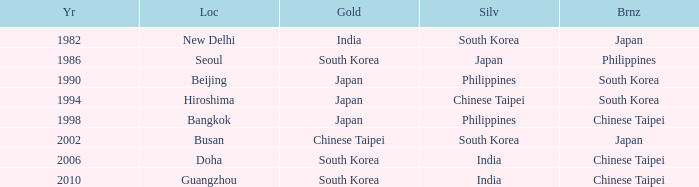Which Location has a Silver of japan? Seoul. 